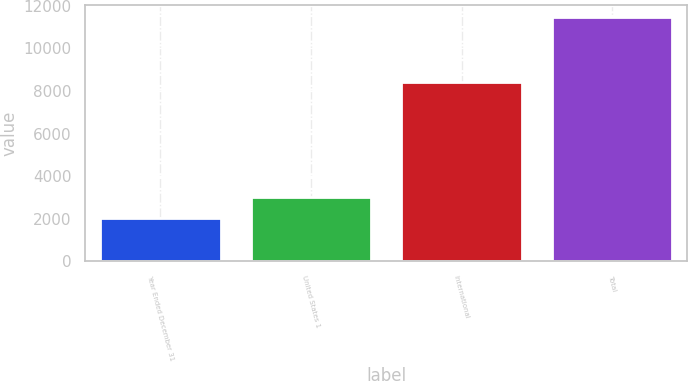Convert chart. <chart><loc_0><loc_0><loc_500><loc_500><bar_chart><fcel>Year Ended December 31<fcel>United States 1<fcel>International<fcel>Total<nl><fcel>2011<fcel>3029<fcel>8429<fcel>11458<nl></chart> 